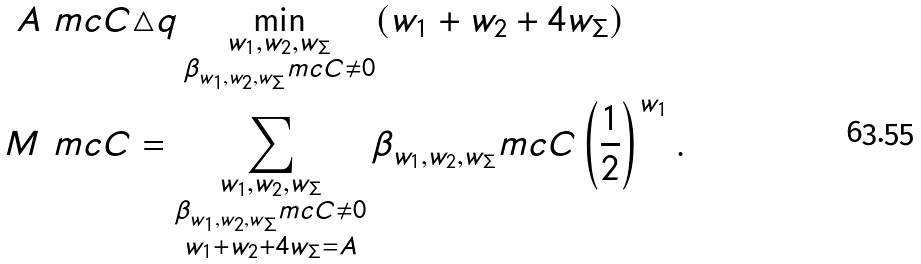Convert formula to latex. <formula><loc_0><loc_0><loc_500><loc_500>A ^ { \ } m c { C } & \triangle q \min _ { \substack { w _ { 1 } , w _ { 2 } , w _ { \Sigma } \\ \beta _ { w _ { 1 } , w _ { 2 } , w _ { \Sigma } } ^ { \ } m c { C } \neq 0 } } ( w _ { 1 } + w _ { 2 } + 4 w _ { \Sigma } ) \\ M ^ { \ } m c { C } & = \sum _ { \substack { w _ { 1 } , w _ { 2 } , w _ { \Sigma } \\ \beta _ { w _ { 1 } , w _ { 2 } , w _ { \Sigma } } ^ { \ } m c { C } \neq 0 \\ w _ { 1 } + w _ { 2 } + 4 w _ { \Sigma } = A } } \beta _ { w _ { 1 } , w _ { 2 } , w _ { \Sigma } } ^ { \ } m c { C } \left ( \frac { 1 } { 2 } \right ) ^ { w _ { 1 } } .</formula> 